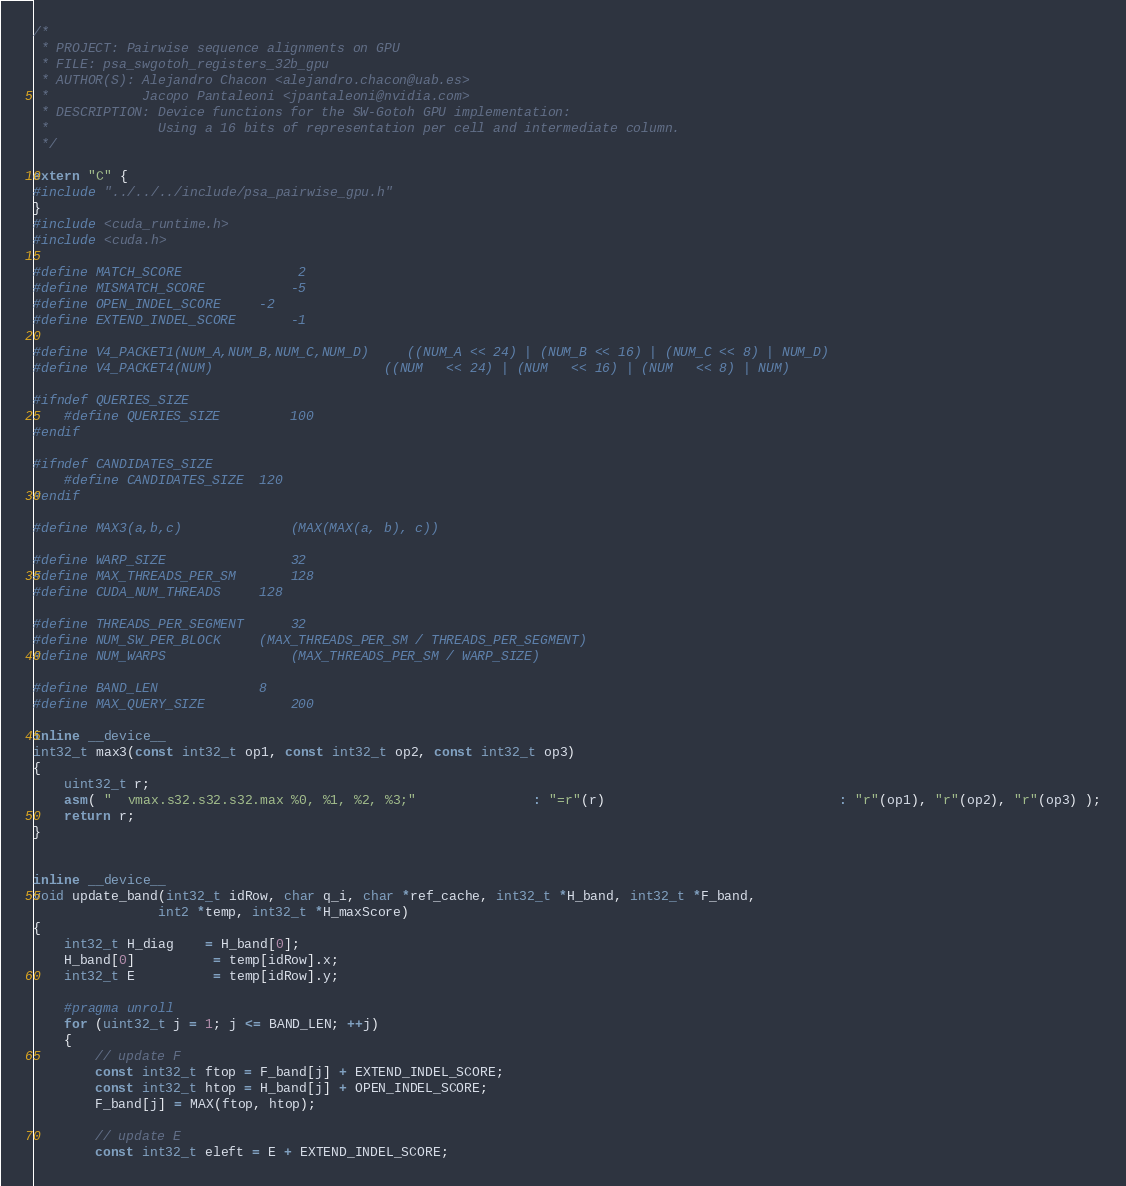<code> <loc_0><loc_0><loc_500><loc_500><_Cuda_>/*
 * PROJECT: Pairwise sequence alignments on GPU
 * FILE: psa_swgotoh_registers_32b_gpu
 * AUTHOR(S): Alejandro Chacon <alejandro.chacon@uab.es>
 *			  Jacopo Pantaleoni <jpantaleoni@nvidia.com>
 * DESCRIPTION: Device functions for the SW-Gotoh GPU implementation:
 *				Using a 16 bits of representation per cell and intermediate column. 
 */

extern "C" {
#include "../../../include/psa_pairwise_gpu.h"
}
#include <cuda_runtime.h>
#include <cuda.h>

#define MATCH_SCORE				 2
#define MISMATCH_SCORE 			-5
#define OPEN_INDEL_SCORE		-2
#define EXTEND_INDEL_SCORE		-1

#define V4_PACKET1(NUM_A,NUM_B,NUM_C,NUM_D)     ((NUM_A << 24) | (NUM_B << 16) | (NUM_C << 8) | NUM_D)
#define V4_PACKET4(NUM) 						((NUM   << 24) | (NUM   << 16) | (NUM   << 8) | NUM)

#ifndef QUERIES_SIZE
	#define QUERIES_SIZE 		100
#endif

#ifndef CANDIDATES_SIZE
	#define CANDIDATES_SIZE 	120
#endif

#define MAX3(a,b,c)				(MAX(MAX(a, b), c))

#define WARP_SIZE				32
#define MAX_THREADS_PER_SM		128
#define CUDA_NUM_THREADS		128

#define THREADS_PER_SEGMENT		32
#define NUM_SW_PER_BLOCK		(MAX_THREADS_PER_SM / THREADS_PER_SEGMENT)
#define NUM_WARPS				(MAX_THREADS_PER_SM / WARP_SIZE)

#define BAND_LEN			 	8
#define MAX_QUERY_SIZE			200

inline __device__
int32_t max3(const int32_t op1, const int32_t op2, const int32_t op3)
{
    uint32_t r;
    asm( "  vmax.s32.s32.s32.max %0, %1, %2, %3;"               : "=r"(r)                              : "r"(op1), "r"(op2), "r"(op3) );
    return r;
}


inline __device__
void update_band(int32_t idRow, char q_i, char *ref_cache, int32_t *H_band, int32_t *F_band,
				int2 *temp, int32_t *H_maxScore)
{
	int32_t H_diag    = H_band[0];
	H_band[0] 		  = temp[idRow].x;
    int32_t E 	      = temp[idRow].y;

    #pragma unroll
    for (uint32_t j = 1; j <= BAND_LEN; ++j)
    {
        // update F
        const int32_t ftop = F_band[j] + EXTEND_INDEL_SCORE;
        const int32_t htop = H_band[j] + OPEN_INDEL_SCORE;
        F_band[j] = MAX(ftop, htop);

        // update E
        const int32_t eleft = E + EXTEND_INDEL_SCORE;</code> 